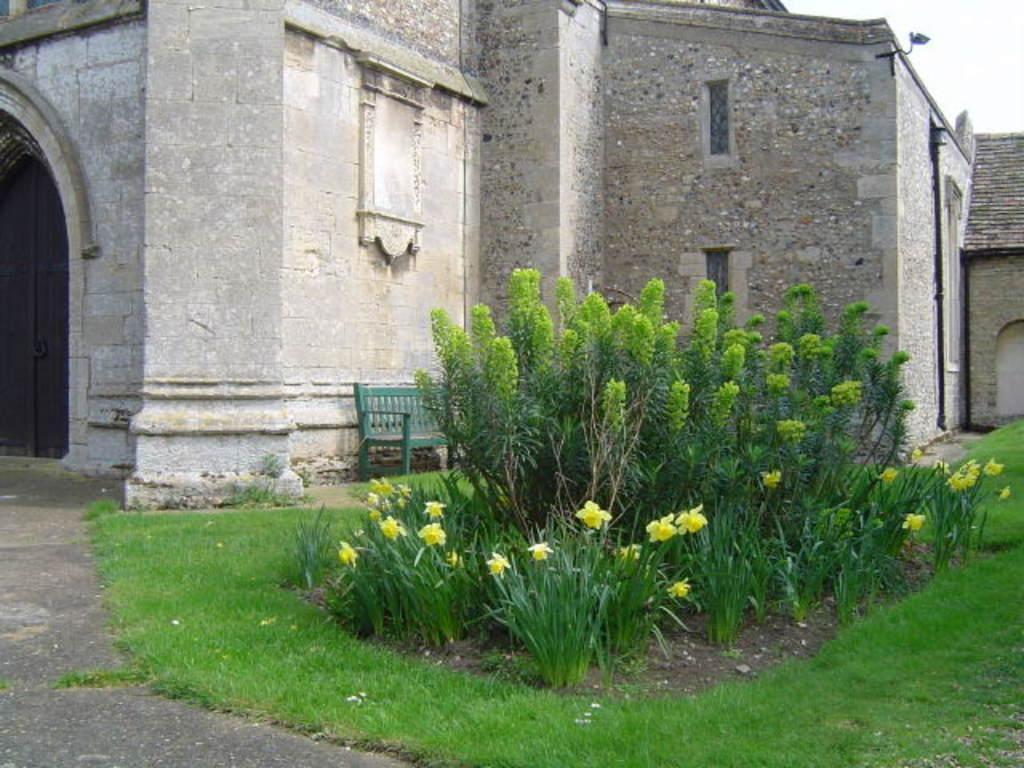Describe this image in one or two sentences. In the center of the image there are plants and flowers. At the bottom of the image there is grass on the surface. In the background of the image there are buildings. In front of the building there is a bench. On the left side of the image there is a closed door. At the top of the image there is sky. 